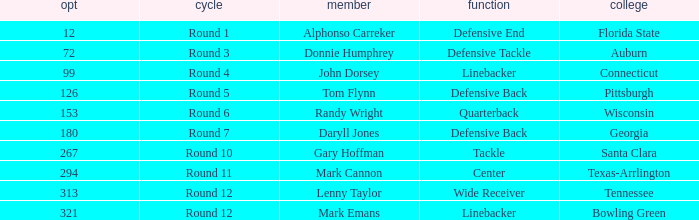Could you help me parse every detail presented in this table? {'header': ['opt', 'cycle', 'member', 'function', 'college'], 'rows': [['12', 'Round 1', 'Alphonso Carreker', 'Defensive End', 'Florida State'], ['72', 'Round 3', 'Donnie Humphrey', 'Defensive Tackle', 'Auburn'], ['99', 'Round 4', 'John Dorsey', 'Linebacker', 'Connecticut'], ['126', 'Round 5', 'Tom Flynn', 'Defensive Back', 'Pittsburgh'], ['153', 'Round 6', 'Randy Wright', 'Quarterback', 'Wisconsin'], ['180', 'Round 7', 'Daryll Jones', 'Defensive Back', 'Georgia'], ['267', 'Round 10', 'Gary Hoffman', 'Tackle', 'Santa Clara'], ['294', 'Round 11', 'Mark Cannon', 'Center', 'Texas-Arrlington'], ['313', 'Round 12', 'Lenny Taylor', 'Wide Receiver', 'Tennessee'], ['321', 'Round 12', 'Mark Emans', 'Linebacker', 'Bowling Green']]} What is the Position of Pick #321? Linebacker. 